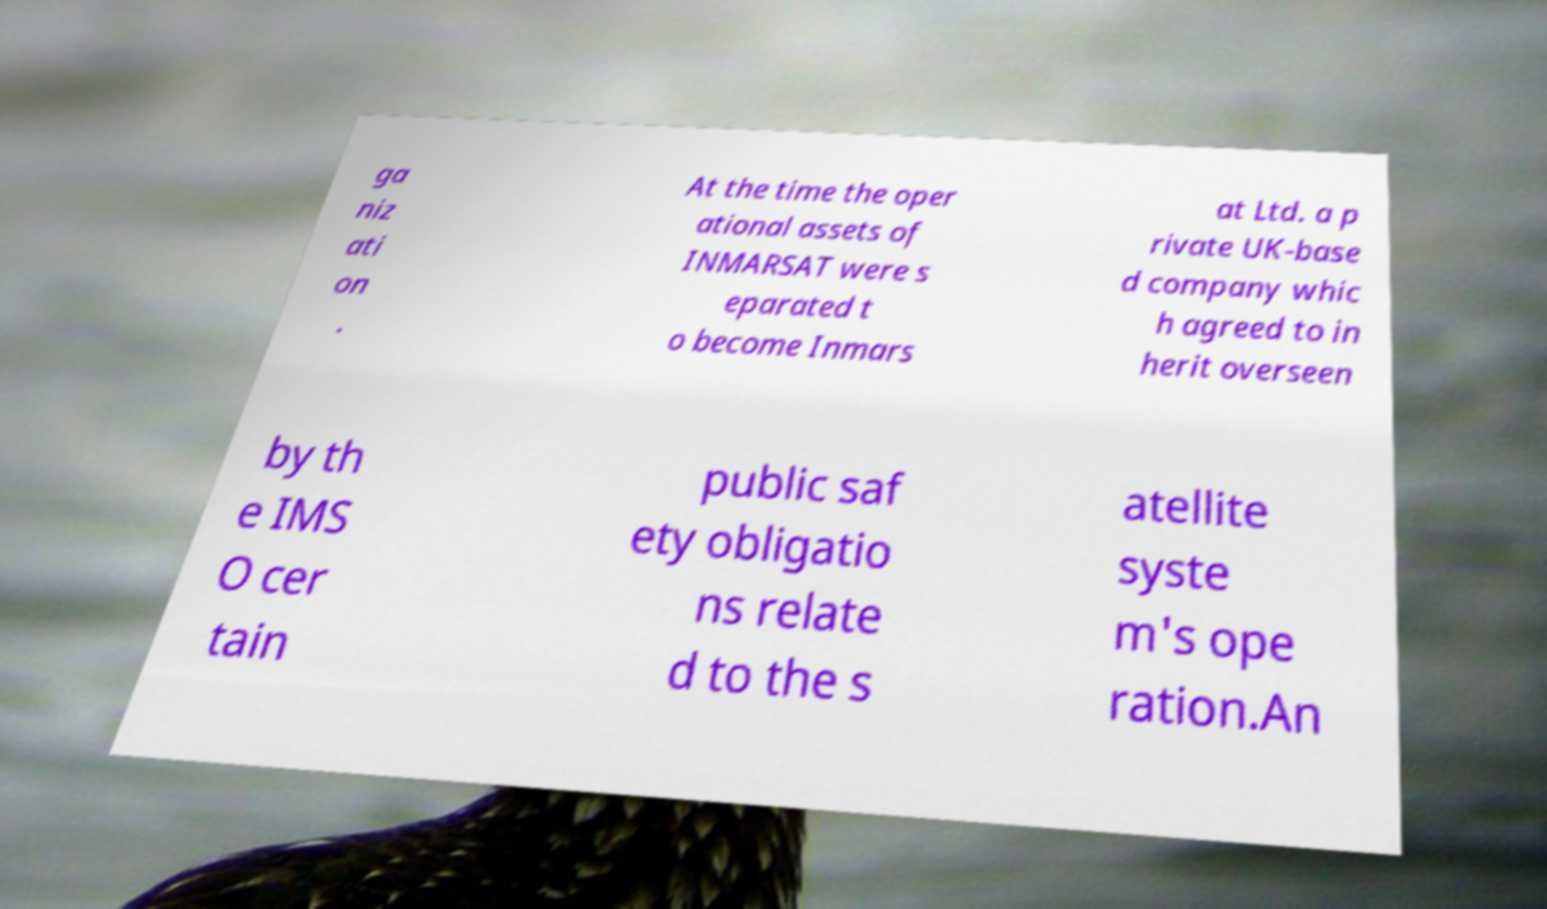Can you accurately transcribe the text from the provided image for me? ga niz ati on . At the time the oper ational assets of INMARSAT were s eparated t o become Inmars at Ltd. a p rivate UK-base d company whic h agreed to in herit overseen by th e IMS O cer tain public saf ety obligatio ns relate d to the s atellite syste m's ope ration.An 